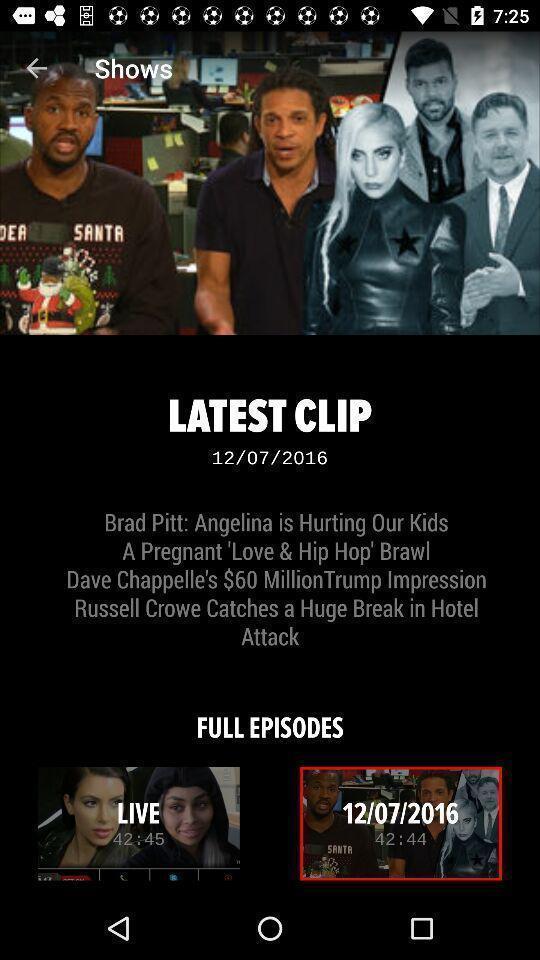Tell me what you see in this picture. Window displaying shows to watch. 